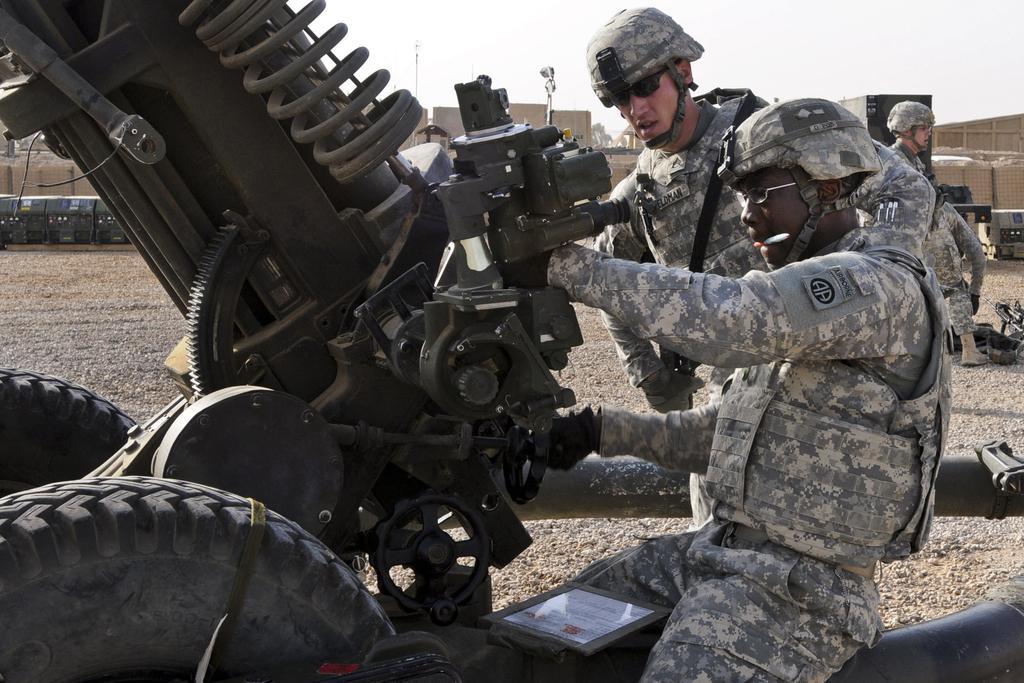What is the person in the image doing? The person is sitting on a machine in the image. Can you describe the scene in the background? There are persons and containers in the background of the image. What type of battle is taking place in the image? There is no battle present in the image; it features a person sitting on a machine and persons and containers in the background. 